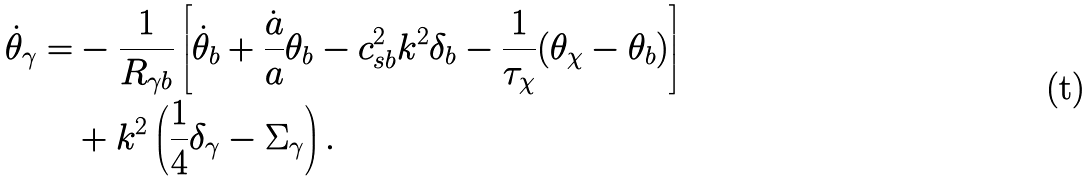<formula> <loc_0><loc_0><loc_500><loc_500>\dot { \theta } _ { \gamma } = & - \frac { 1 } { R _ { \gamma b } } \left [ \dot { \theta } _ { b } + \frac { \dot { a } } { a } \theta _ { b } - c _ { s b } ^ { 2 } k ^ { 2 } \delta _ { b } - \frac { 1 } { \tau _ { \chi } } ( \theta _ { \chi } - \theta _ { b } ) \right ] \\ & + k ^ { 2 } \left ( \frac { 1 } { 4 } \delta _ { \gamma } - \Sigma _ { \gamma } \right ) .</formula> 